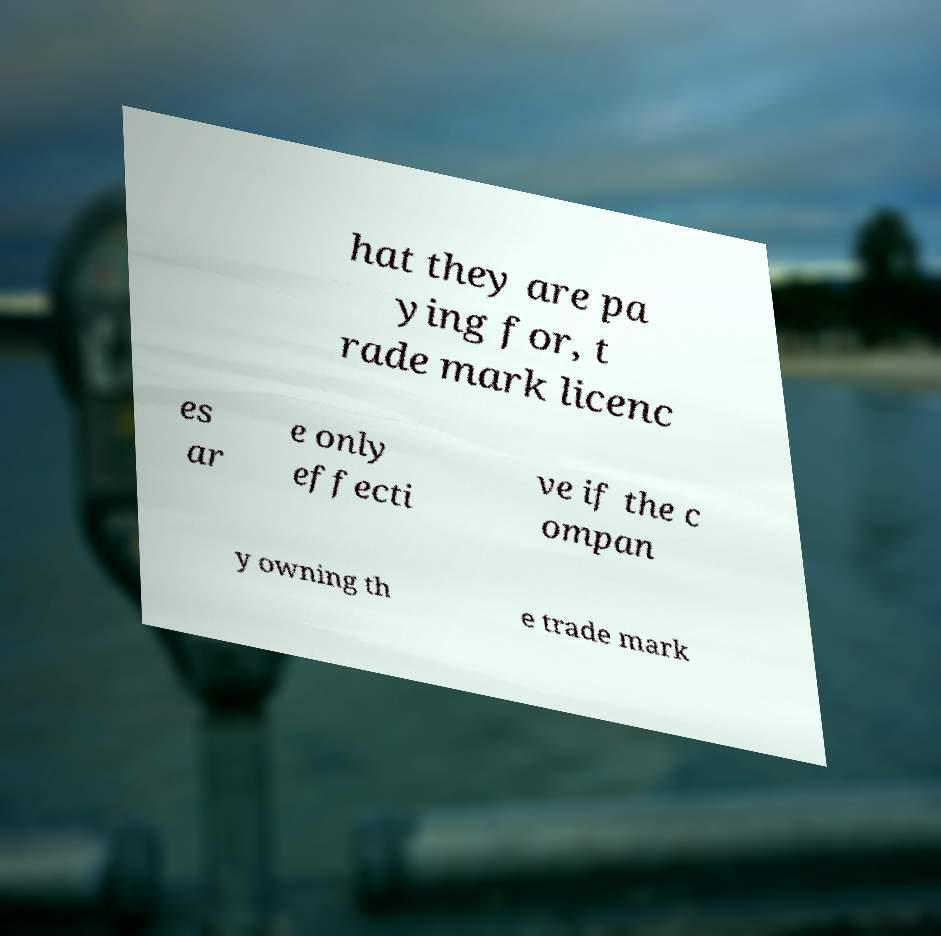Please identify and transcribe the text found in this image. hat they are pa ying for, t rade mark licenc es ar e only effecti ve if the c ompan y owning th e trade mark 